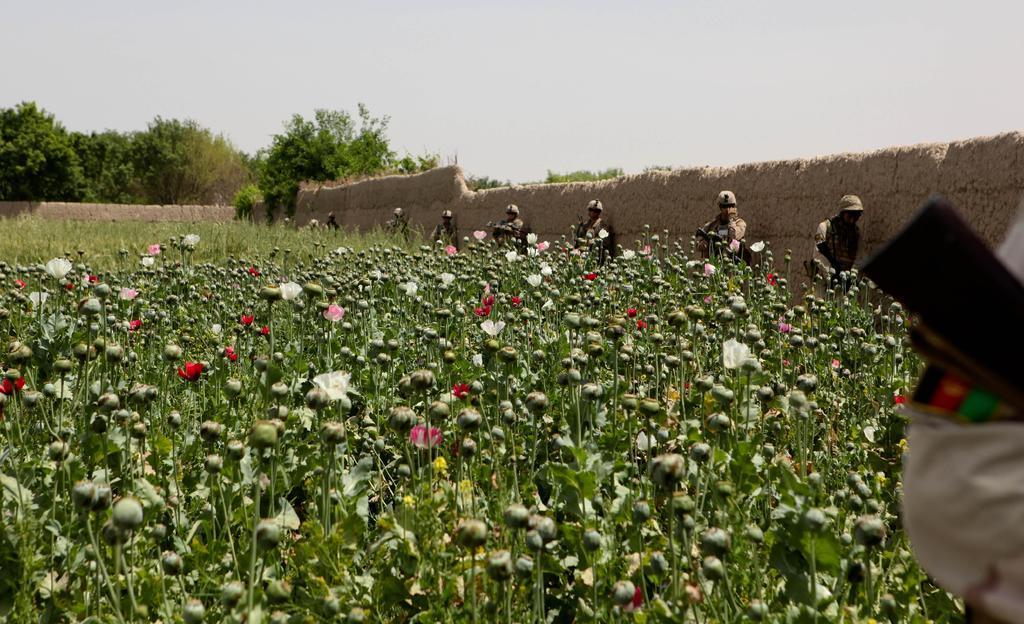How would you summarize this image in a sentence or two? In this picture there are group of people standing at the wall and holding the guns. On the right side of the image there is a person standing and holding the gun. At the back there are trees and there is a wall. In the foreground there are flowers and buds on the plants. At the top there is sky. 